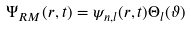Convert formula to latex. <formula><loc_0><loc_0><loc_500><loc_500>\Psi _ { R M } ( { r } , t ) = \psi _ { n , l } ( r , t ) \Theta _ { l } ( \vartheta )</formula> 